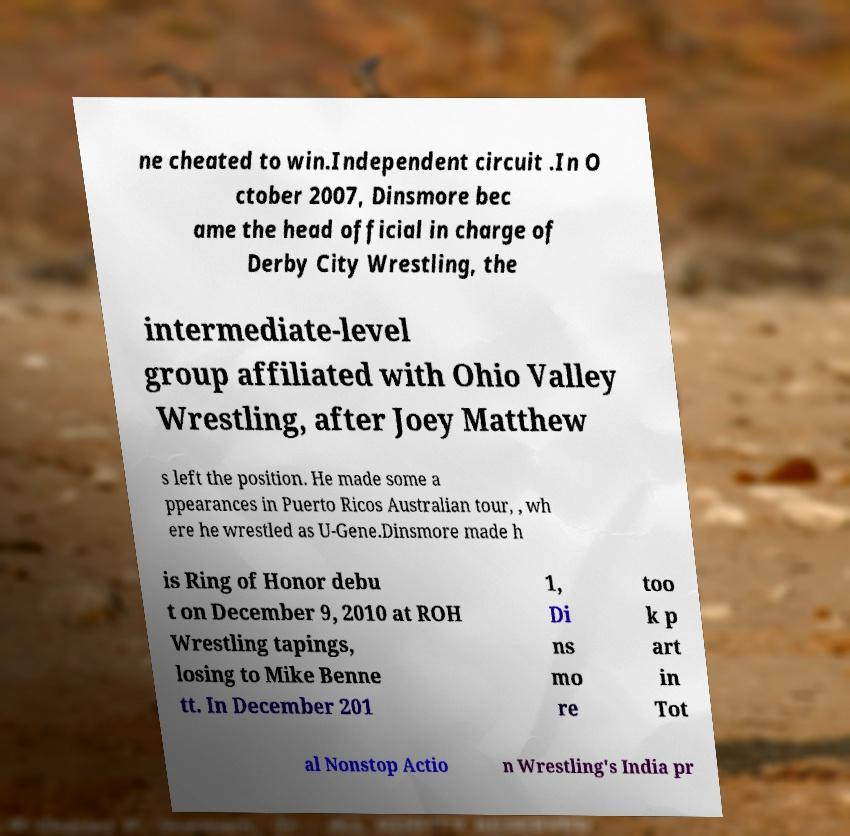What messages or text are displayed in this image? I need them in a readable, typed format. ne cheated to win.Independent circuit .In O ctober 2007, Dinsmore bec ame the head official in charge of Derby City Wrestling, the intermediate-level group affiliated with Ohio Valley Wrestling, after Joey Matthew s left the position. He made some a ppearances in Puerto Ricos Australian tour, , wh ere he wrestled as U-Gene.Dinsmore made h is Ring of Honor debu t on December 9, 2010 at ROH Wrestling tapings, losing to Mike Benne tt. In December 201 1, Di ns mo re too k p art in Tot al Nonstop Actio n Wrestling's India pr 